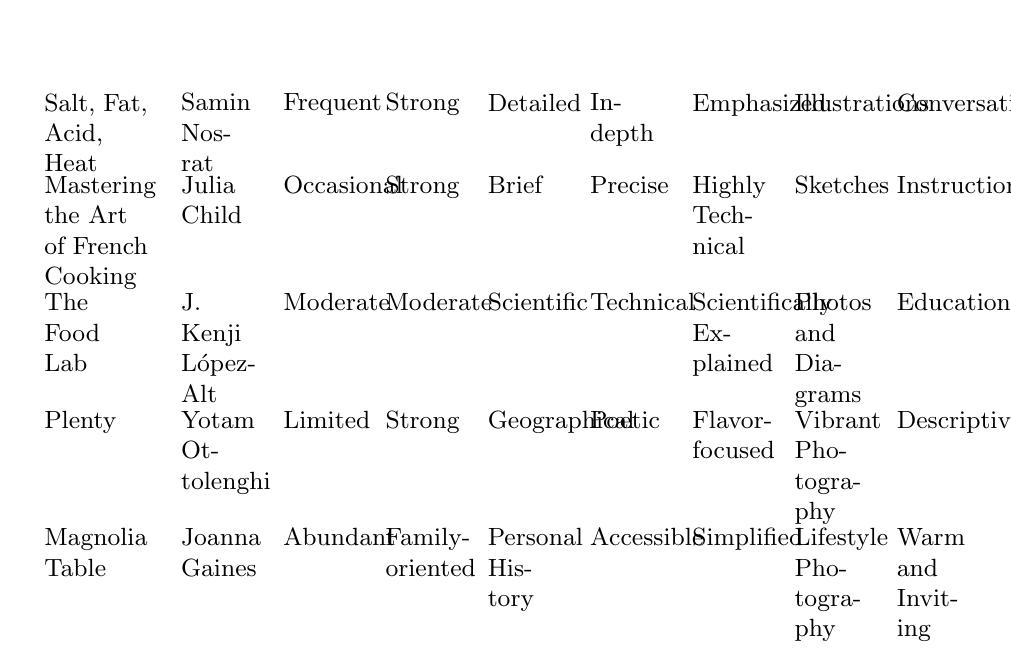What storytelling technique is emphasized in "Salt, Fat, Acid, Heat"? The table shows that in "Salt, Fat, Acid, Heat," Samin Nosrat emphasizes cooking principles.
Answer: Emphasized Which cookbook has the most personal anecdotes? By comparing the "Personal Anecdotes" column, "Magnolia Table" has abundant personal anecdotes, which is the highest in this category.
Answer: Abundant Is the narrative style of "The Food Lab" educational? The table indicates that "The Food Lab" by J. Kenji López-Alt has an educational narrative style, making this statement true.
Answer: Yes How many cookbooks emphasize cultural context strongly? The cookbooks "Salt, Fat, Acid, Heat," "Mastering the Art of French Cooking," "Plenty," and "Magnolia Table" all have a strong cultural context, constituting a total of four cookbooks.
Answer: 4 Does "Plenty" have in-depth ingredient descriptions? The ingredient descriptions in "Plenty" are listed as poetic in the table, which means this statement is false.
Answer: No Which cookbook combines technical ingredient descriptions with scientific recipe origins? "The Food Lab" combines technical ingredient descriptions with scientific recipe origins according to the relevant columns in the table.
Answer: The Food Lab What is the narrative style of "Magnolia Table"? The table states that Joanna Gaines's "Magnolia Table" uses a warm and inviting narrative style.
Answer: Warm and Inviting What is the difference in the number of personal anecdotes between "Salt, Fat, Acid, Heat" and "Mastering the Art of French Cooking"? "Salt, Fat, Acid, Heat" has frequent personal anecdotes, while "Mastering the Art of French Cooking" has occasional ones. The difference is between frequent and occasional, which indicates a high level of anecdotes versus a relatively lower amount.
Answer: Moderate difference Which cookbook utilizes vibrant photography as visual aids? The table states that "Plenty" by Yotam Ottolenghi utilizes vibrant photography as visual aids, thus answering the question specifically.
Answer: Plenty 